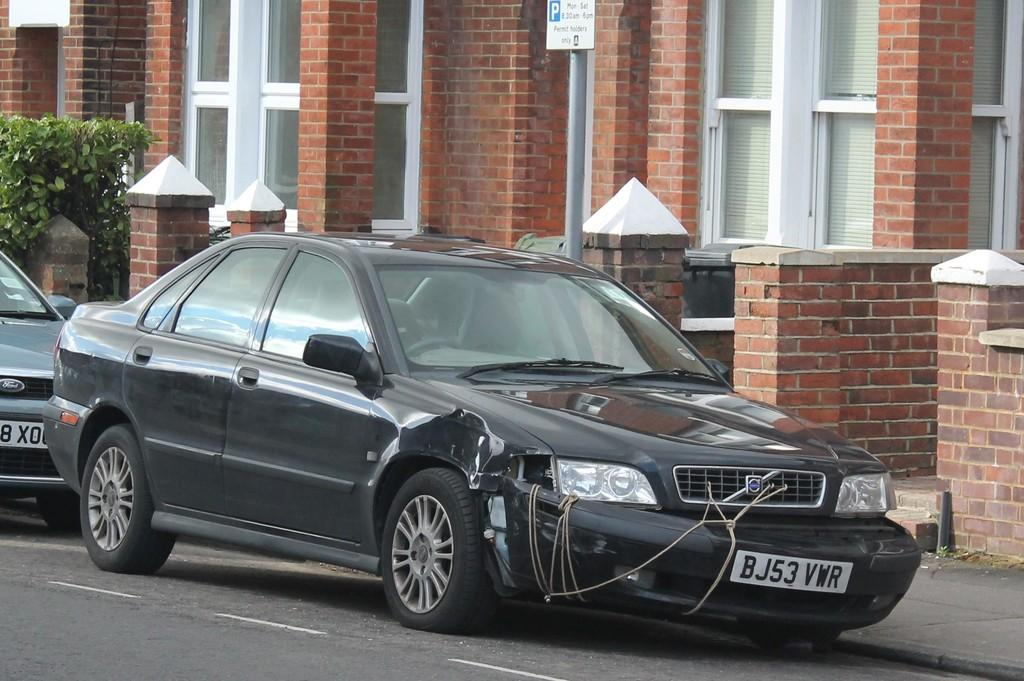<image>
Give a short and clear explanation of the subsequent image. A car with a falling off front bumber with a tag that says BJ53 VWR. 